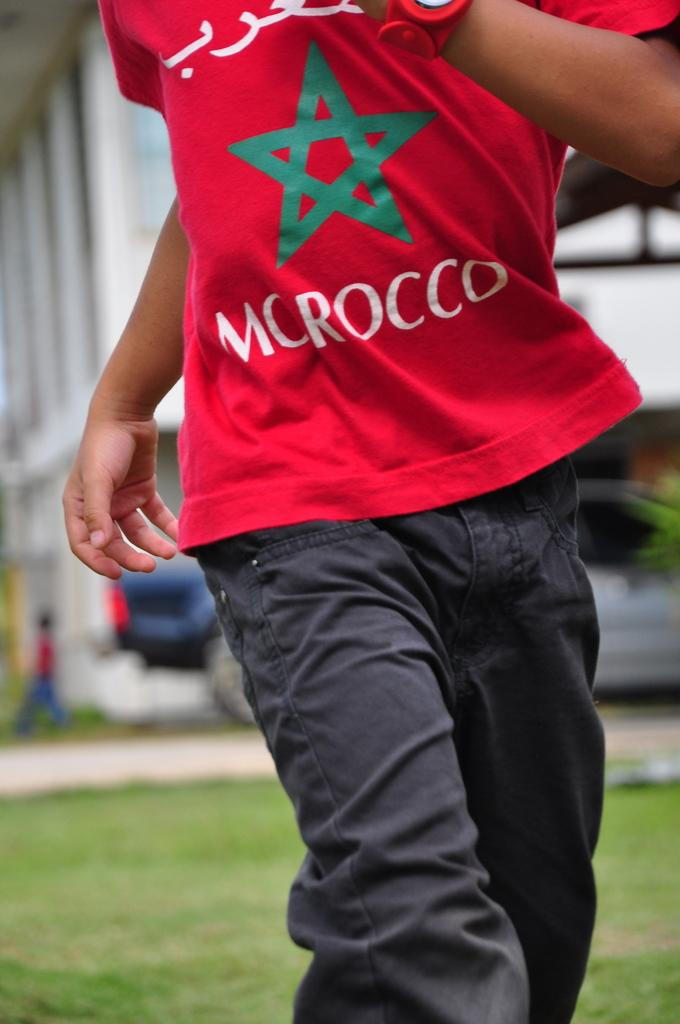<image>
Share a concise interpretation of the image provided. A person seen only from the neck down wears an orange Morocco tee shirt. 